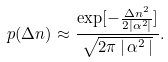<formula> <loc_0><loc_0><loc_500><loc_500>p ( \Delta n ) \approx \frac { \exp [ - \frac { \Delta n ^ { 2 } } { 2 | \alpha ^ { 2 } | } ] } { \sqrt { 2 \pi \, | \, \alpha ^ { 2 } \, | } } .</formula> 